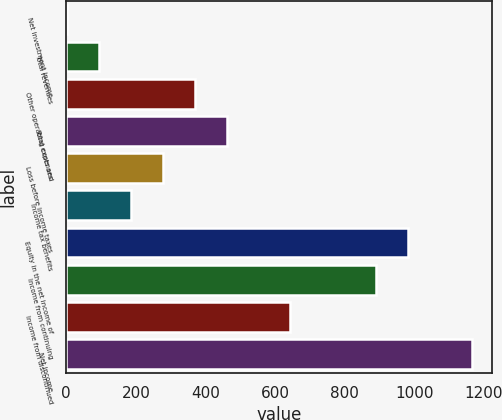Convert chart to OTSL. <chart><loc_0><loc_0><loc_500><loc_500><bar_chart><fcel>Net investment income<fcel>Total revenues<fcel>Other operating costs and<fcel>Total expenses<fcel>Loss before income taxes<fcel>Income tax benefits<fcel>Equity in the net income of<fcel>Income from continuing<fcel>Income from discontinued<fcel>Net income<nl><fcel>2.3<fcel>93.97<fcel>368.98<fcel>460.65<fcel>277.31<fcel>185.64<fcel>981.87<fcel>890.2<fcel>643.99<fcel>1165.21<nl></chart> 